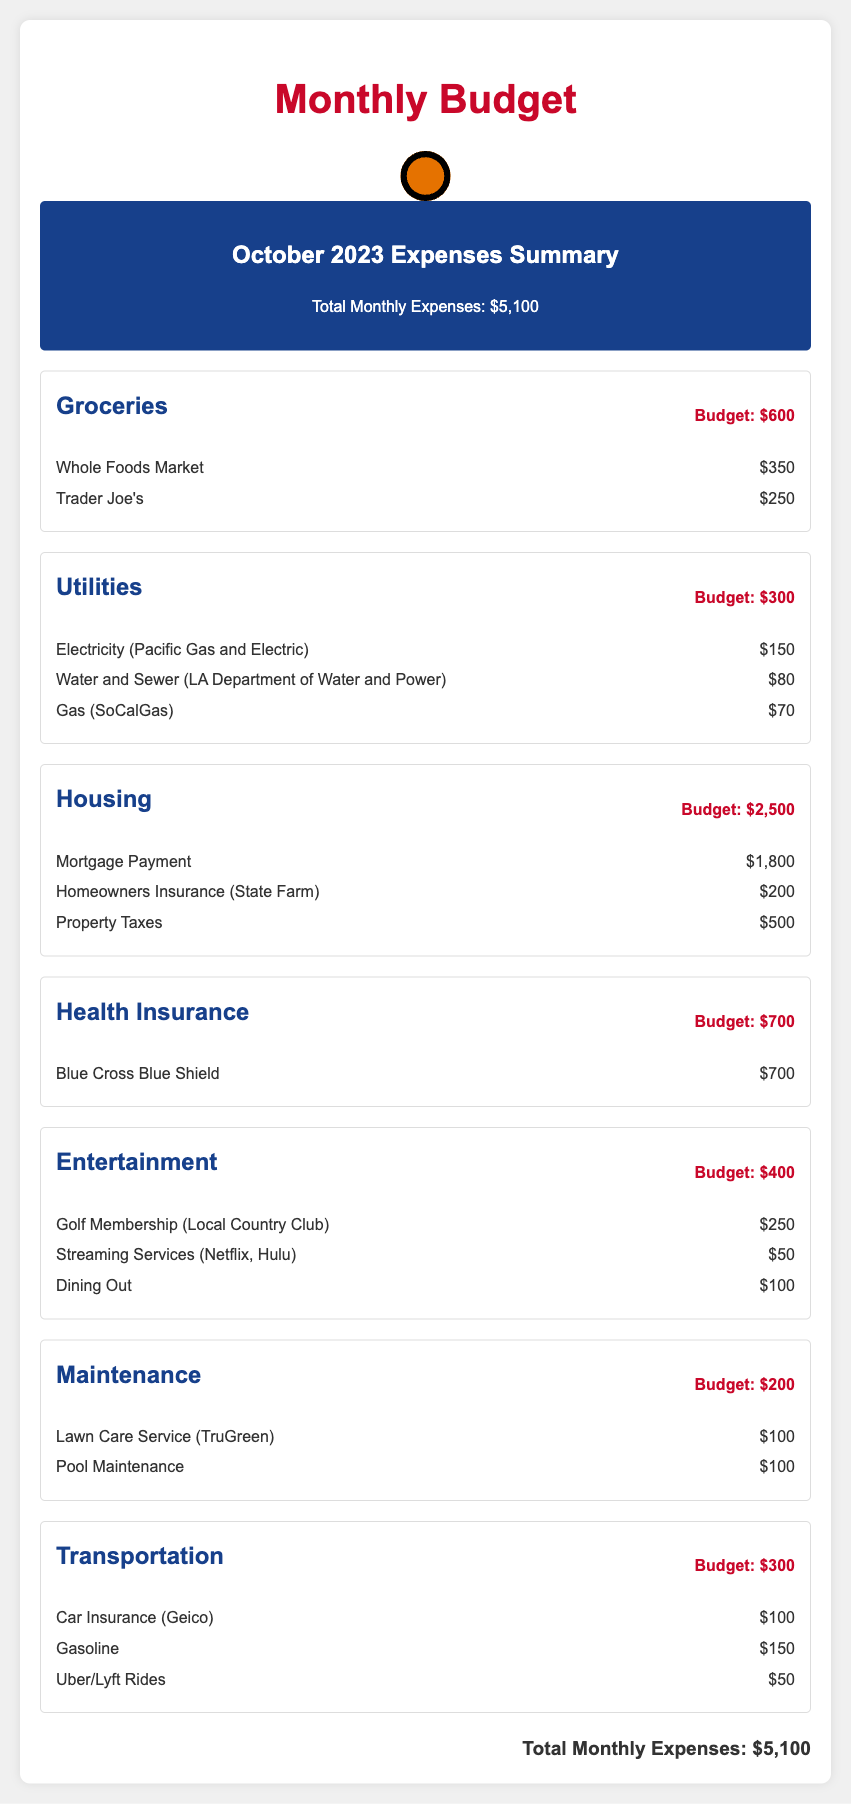What is the total monthly expenses? The total monthly expenses are listed in the summary section of the document, which is $5,100.
Answer: $5,100 What is the budget for groceries? The budget for groceries is specified in the groceries section of the document, which is $600.
Answer: $600 How much was spent on Blue Cross Blue Shield? The amount spent on Blue Cross Blue Shield is detailed in the health insurance section, which is $700.
Answer: $700 What is the sum of the entertainment expenses? The entertainment expenses are detailed as $250 for Golf Membership, $50 for Streaming Services, and $100 for Dining Out, totaling $400.
Answer: $400 How much did the homeowner pay for property taxes? The document outlines the property taxes under the housing category, which is $500.
Answer: $500 What utility had the highest expense? The highest utility expense listed is for Electricity (Pacific Gas and Electric), which costs $150.
Answer: Electricity What is the total transportation budget? The total budget for transportation is indicated in the transportation section of the document, which is $300.
Answer: $300 How many categories of expenses are listed? The document presents seven categories of expenses, detailed in separate sections.
Answer: Seven What was the cost of lawn care service? The lawn care service cost is specified in the maintenance section at $100.
Answer: $100 